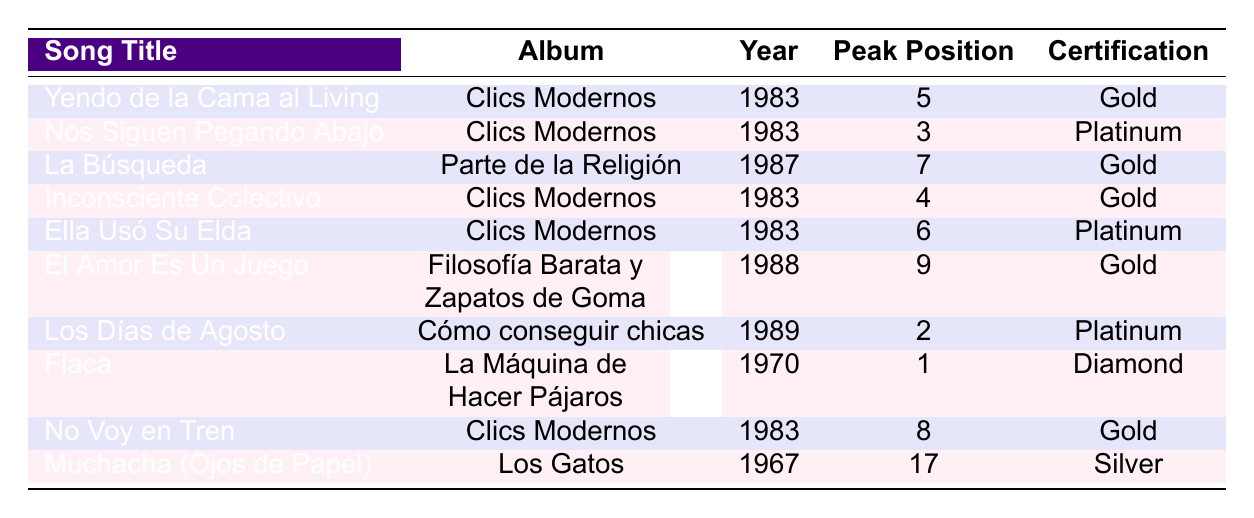What is the peak chart position of "Nos Siguen Pegando Abajo"? The table lists "Nos Siguen Pegando Abajo" with a peak chart position of 3.
Answer: 3 How many years did "Ella Usó Su Elda" stay in the chart? According to the table, "Ella Usó Su Elda" lasted for 7 years in the chart.
Answer: 7 Which song has the highest certification? The table shows "Flaca" with a certification of Diamond, which is the highest certification listed.
Answer: Diamond Which song from the album "Clics Modernos" peaked at position 8? The table notes that "No Voy en Tren" is from "Clics Modernos" and peaked at position 8.
Answer: No Voy en Tren What is the average peak position of songs from the album "Clics Modernos"? The peak positions for songs from "Clics Modernos" are 5, 3, 4, 6, and 8; summing these yields 26, and dividing by 5 gives an average of 5.2.
Answer: 5.2 How many songs peaked above position 5? Checking the peak positions of all songs, they are 5, 3, 7, 4, 6, 9, 2, 1, 8, and 17. The positions above 5 are 3, 7, 6, 9, 2, 1, and 17, which totals 7 songs.
Answer: 7 Is "La Búsqueda" certified Platinum? The table indicates that "La Búsqueda" has a Gold certification, so it is not Platinum.
Answer: No Which song has the longest chart presence and its peak position? "Flaca" has the longest chart presence at 15 years and peaked at position 1, according to the table.
Answer: 15 years, position 1 What is the genre of the song "El Amor Es Un Juego"? The table categorizes "El Amor Es Un Juego" as Pop Rock.
Answer: Pop Rock Do any songs from the table span more than 10 years in the chart? Yes, the song "Flaca" has 15 years in the chart, which is more than 10 years.
Answer: Yes 